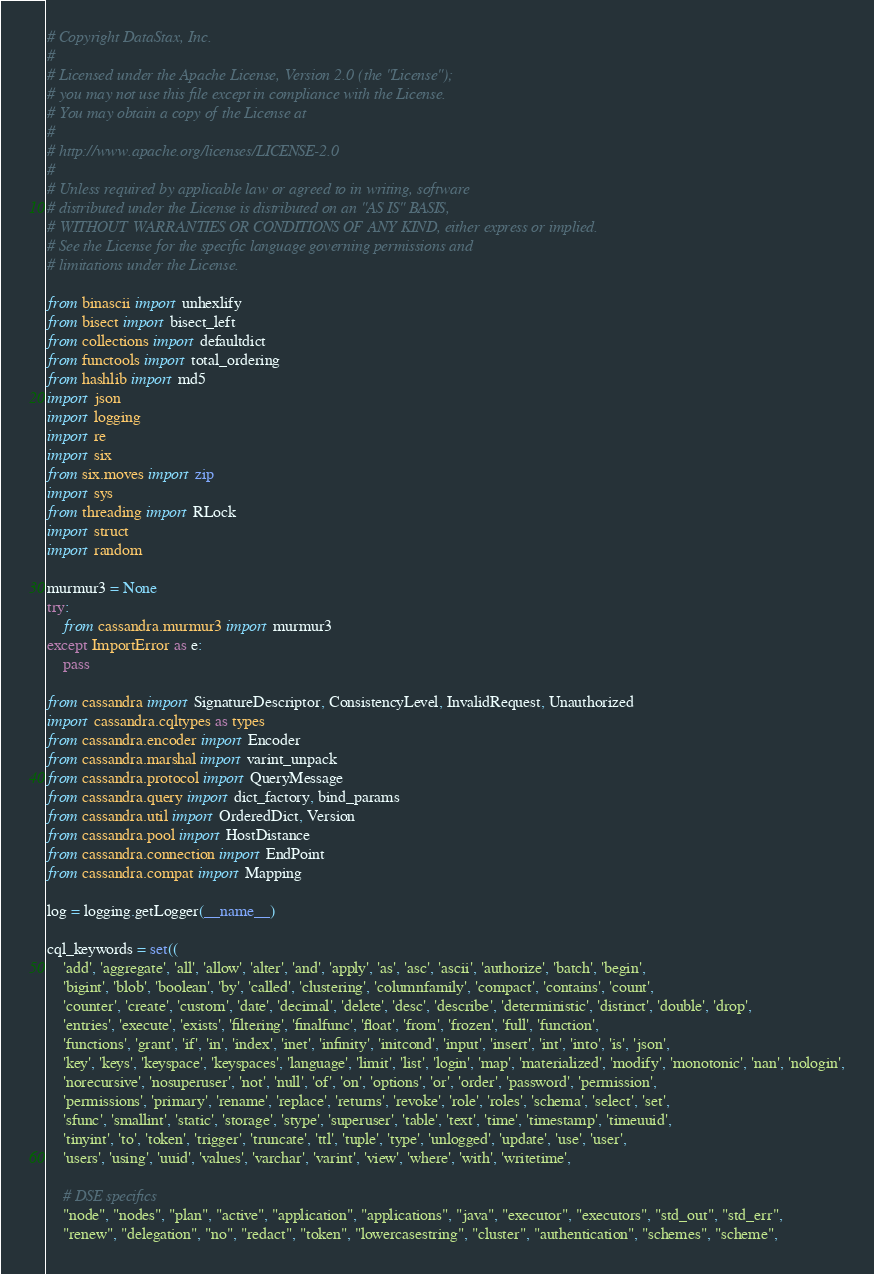Convert code to text. <code><loc_0><loc_0><loc_500><loc_500><_Python_># Copyright DataStax, Inc.
#
# Licensed under the Apache License, Version 2.0 (the "License");
# you may not use this file except in compliance with the License.
# You may obtain a copy of the License at
#
# http://www.apache.org/licenses/LICENSE-2.0
#
# Unless required by applicable law or agreed to in writing, software
# distributed under the License is distributed on an "AS IS" BASIS,
# WITHOUT WARRANTIES OR CONDITIONS OF ANY KIND, either express or implied.
# See the License for the specific language governing permissions and
# limitations under the License.

from binascii import unhexlify
from bisect import bisect_left
from collections import defaultdict
from functools import total_ordering
from hashlib import md5
import json
import logging
import re
import six
from six.moves import zip
import sys
from threading import RLock
import struct
import random

murmur3 = None
try:
    from cassandra.murmur3 import murmur3
except ImportError as e:
    pass

from cassandra import SignatureDescriptor, ConsistencyLevel, InvalidRequest, Unauthorized
import cassandra.cqltypes as types
from cassandra.encoder import Encoder
from cassandra.marshal import varint_unpack
from cassandra.protocol import QueryMessage
from cassandra.query import dict_factory, bind_params
from cassandra.util import OrderedDict, Version
from cassandra.pool import HostDistance
from cassandra.connection import EndPoint
from cassandra.compat import Mapping

log = logging.getLogger(__name__)

cql_keywords = set((
    'add', 'aggregate', 'all', 'allow', 'alter', 'and', 'apply', 'as', 'asc', 'ascii', 'authorize', 'batch', 'begin',
    'bigint', 'blob', 'boolean', 'by', 'called', 'clustering', 'columnfamily', 'compact', 'contains', 'count',
    'counter', 'create', 'custom', 'date', 'decimal', 'delete', 'desc', 'describe', 'deterministic', 'distinct', 'double', 'drop',
    'entries', 'execute', 'exists', 'filtering', 'finalfunc', 'float', 'from', 'frozen', 'full', 'function',
    'functions', 'grant', 'if', 'in', 'index', 'inet', 'infinity', 'initcond', 'input', 'insert', 'int', 'into', 'is', 'json',
    'key', 'keys', 'keyspace', 'keyspaces', 'language', 'limit', 'list', 'login', 'map', 'materialized', 'modify', 'monotonic', 'nan', 'nologin',
    'norecursive', 'nosuperuser', 'not', 'null', 'of', 'on', 'options', 'or', 'order', 'password', 'permission',
    'permissions', 'primary', 'rename', 'replace', 'returns', 'revoke', 'role', 'roles', 'schema', 'select', 'set',
    'sfunc', 'smallint', 'static', 'storage', 'stype', 'superuser', 'table', 'text', 'time', 'timestamp', 'timeuuid',
    'tinyint', 'to', 'token', 'trigger', 'truncate', 'ttl', 'tuple', 'type', 'unlogged', 'update', 'use', 'user',
    'users', 'using', 'uuid', 'values', 'varchar', 'varint', 'view', 'where', 'with', 'writetime',

    # DSE specifics
    "node", "nodes", "plan", "active", "application", "applications", "java", "executor", "executors", "std_out", "std_err",
    "renew", "delegation", "no", "redact", "token", "lowercasestring", "cluster", "authentication", "schemes", "scheme",</code> 